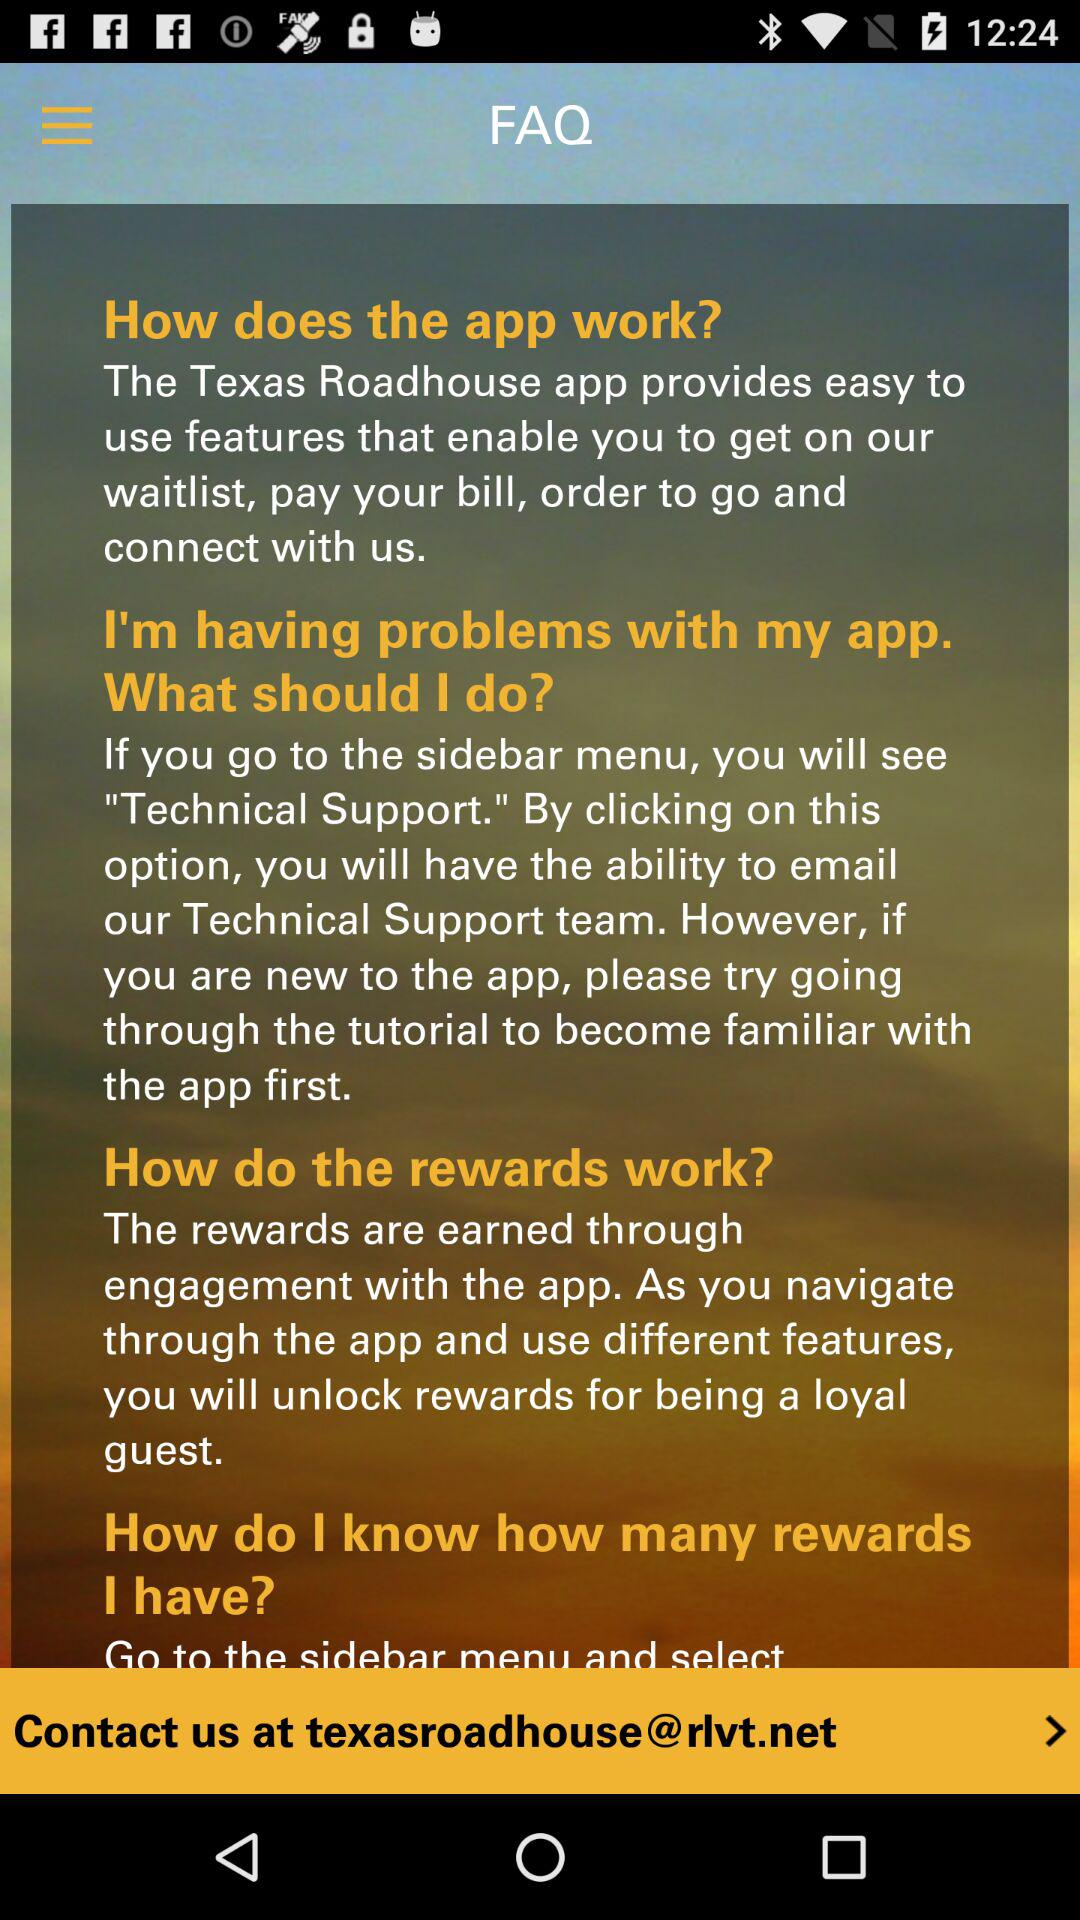What is the contact email ID? The contact email ID is "texasroadhouse@rlvt.net". 